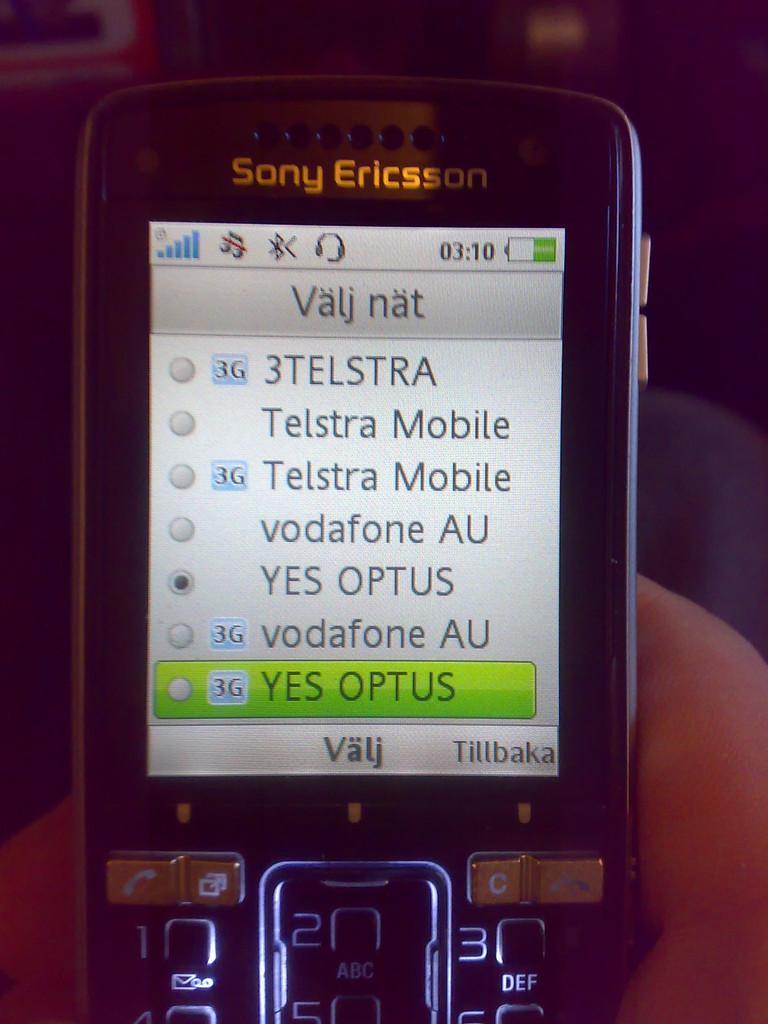<image>
Present a compact description of the photo's key features. The front of a sony ericsson branded phone with a light up keyboard. 